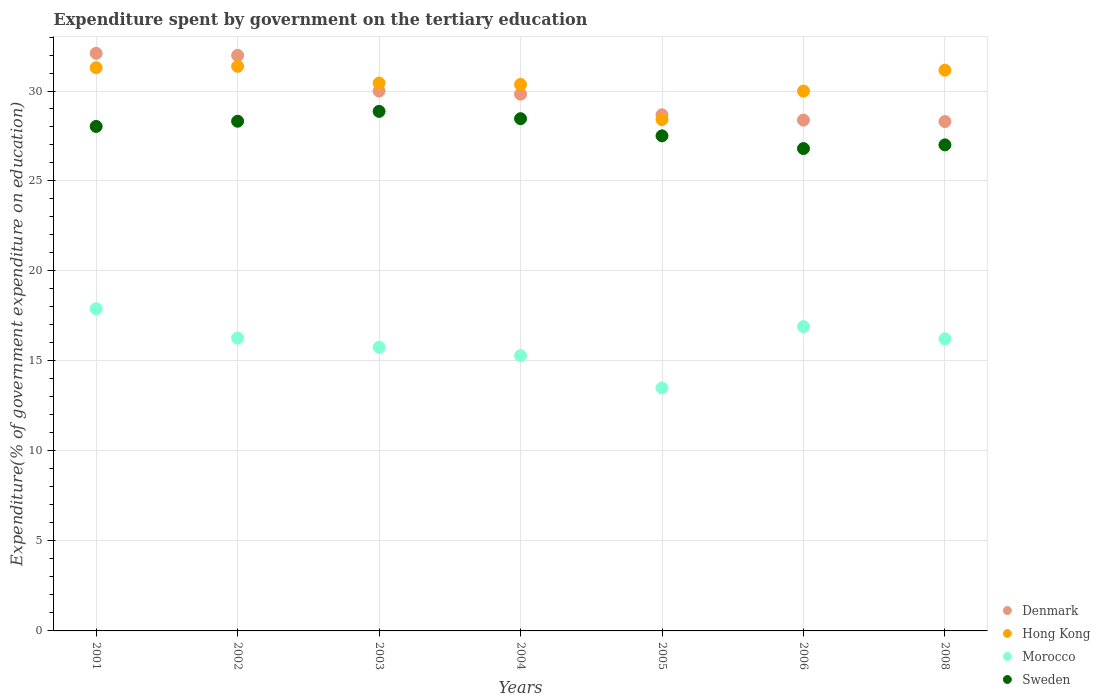How many different coloured dotlines are there?
Offer a terse response. 4. What is the expenditure spent by government on the tertiary education in Hong Kong in 2005?
Your answer should be very brief. 28.41. Across all years, what is the maximum expenditure spent by government on the tertiary education in Morocco?
Offer a terse response. 17.9. Across all years, what is the minimum expenditure spent by government on the tertiary education in Denmark?
Your answer should be very brief. 28.3. In which year was the expenditure spent by government on the tertiary education in Sweden maximum?
Offer a terse response. 2003. What is the total expenditure spent by government on the tertiary education in Hong Kong in the graph?
Provide a succinct answer. 213.04. What is the difference between the expenditure spent by government on the tertiary education in Hong Kong in 2001 and that in 2002?
Make the answer very short. -0.07. What is the difference between the expenditure spent by government on the tertiary education in Sweden in 2004 and the expenditure spent by government on the tertiary education in Denmark in 2005?
Make the answer very short. -0.22. What is the average expenditure spent by government on the tertiary education in Sweden per year?
Provide a succinct answer. 27.86. In the year 2005, what is the difference between the expenditure spent by government on the tertiary education in Denmark and expenditure spent by government on the tertiary education in Morocco?
Offer a terse response. 15.18. In how many years, is the expenditure spent by government on the tertiary education in Hong Kong greater than 29 %?
Ensure brevity in your answer.  6. What is the ratio of the expenditure spent by government on the tertiary education in Denmark in 2002 to that in 2006?
Offer a very short reply. 1.13. Is the expenditure spent by government on the tertiary education in Denmark in 2003 less than that in 2008?
Make the answer very short. No. What is the difference between the highest and the second highest expenditure spent by government on the tertiary education in Hong Kong?
Keep it short and to the point. 0.07. What is the difference between the highest and the lowest expenditure spent by government on the tertiary education in Sweden?
Your response must be concise. 2.07. In how many years, is the expenditure spent by government on the tertiary education in Denmark greater than the average expenditure spent by government on the tertiary education in Denmark taken over all years?
Provide a succinct answer. 3. Is the sum of the expenditure spent by government on the tertiary education in Hong Kong in 2003 and 2004 greater than the maximum expenditure spent by government on the tertiary education in Morocco across all years?
Provide a succinct answer. Yes. Is it the case that in every year, the sum of the expenditure spent by government on the tertiary education in Sweden and expenditure spent by government on the tertiary education in Denmark  is greater than the sum of expenditure spent by government on the tertiary education in Hong Kong and expenditure spent by government on the tertiary education in Morocco?
Make the answer very short. Yes. Does the expenditure spent by government on the tertiary education in Denmark monotonically increase over the years?
Keep it short and to the point. No. How many dotlines are there?
Your answer should be very brief. 4. How many years are there in the graph?
Ensure brevity in your answer.  7. Where does the legend appear in the graph?
Provide a succinct answer. Bottom right. What is the title of the graph?
Offer a terse response. Expenditure spent by government on the tertiary education. Does "Sweden" appear as one of the legend labels in the graph?
Provide a succinct answer. Yes. What is the label or title of the Y-axis?
Your response must be concise. Expenditure(% of government expenditure on education). What is the Expenditure(% of government expenditure on education) in Denmark in 2001?
Your answer should be compact. 32.09. What is the Expenditure(% of government expenditure on education) of Hong Kong in 2001?
Your response must be concise. 31.3. What is the Expenditure(% of government expenditure on education) of Morocco in 2001?
Keep it short and to the point. 17.9. What is the Expenditure(% of government expenditure on education) of Sweden in 2001?
Your answer should be compact. 28.03. What is the Expenditure(% of government expenditure on education) in Denmark in 2002?
Your response must be concise. 31.98. What is the Expenditure(% of government expenditure on education) of Hong Kong in 2002?
Provide a short and direct response. 31.37. What is the Expenditure(% of government expenditure on education) of Morocco in 2002?
Provide a short and direct response. 16.27. What is the Expenditure(% of government expenditure on education) in Sweden in 2002?
Give a very brief answer. 28.32. What is the Expenditure(% of government expenditure on education) of Denmark in 2003?
Provide a short and direct response. 30. What is the Expenditure(% of government expenditure on education) of Hong Kong in 2003?
Your response must be concise. 30.44. What is the Expenditure(% of government expenditure on education) of Morocco in 2003?
Give a very brief answer. 15.76. What is the Expenditure(% of government expenditure on education) of Sweden in 2003?
Ensure brevity in your answer.  28.87. What is the Expenditure(% of government expenditure on education) in Denmark in 2004?
Provide a short and direct response. 29.82. What is the Expenditure(% of government expenditure on education) in Hong Kong in 2004?
Provide a short and direct response. 30.36. What is the Expenditure(% of government expenditure on education) of Morocco in 2004?
Offer a terse response. 15.29. What is the Expenditure(% of government expenditure on education) of Sweden in 2004?
Ensure brevity in your answer.  28.46. What is the Expenditure(% of government expenditure on education) in Denmark in 2005?
Offer a terse response. 28.68. What is the Expenditure(% of government expenditure on education) of Hong Kong in 2005?
Your answer should be very brief. 28.41. What is the Expenditure(% of government expenditure on education) of Morocco in 2005?
Your answer should be very brief. 13.5. What is the Expenditure(% of government expenditure on education) of Sweden in 2005?
Give a very brief answer. 27.51. What is the Expenditure(% of government expenditure on education) in Denmark in 2006?
Ensure brevity in your answer.  28.38. What is the Expenditure(% of government expenditure on education) of Hong Kong in 2006?
Give a very brief answer. 30. What is the Expenditure(% of government expenditure on education) of Morocco in 2006?
Your response must be concise. 16.91. What is the Expenditure(% of government expenditure on education) in Sweden in 2006?
Your answer should be very brief. 26.8. What is the Expenditure(% of government expenditure on education) in Denmark in 2008?
Your answer should be very brief. 28.3. What is the Expenditure(% of government expenditure on education) of Hong Kong in 2008?
Provide a short and direct response. 31.16. What is the Expenditure(% of government expenditure on education) of Morocco in 2008?
Offer a very short reply. 16.23. What is the Expenditure(% of government expenditure on education) in Sweden in 2008?
Your response must be concise. 27.01. Across all years, what is the maximum Expenditure(% of government expenditure on education) in Denmark?
Provide a short and direct response. 32.09. Across all years, what is the maximum Expenditure(% of government expenditure on education) in Hong Kong?
Your answer should be very brief. 31.37. Across all years, what is the maximum Expenditure(% of government expenditure on education) in Morocco?
Offer a very short reply. 17.9. Across all years, what is the maximum Expenditure(% of government expenditure on education) in Sweden?
Offer a very short reply. 28.87. Across all years, what is the minimum Expenditure(% of government expenditure on education) in Denmark?
Ensure brevity in your answer.  28.3. Across all years, what is the minimum Expenditure(% of government expenditure on education) in Hong Kong?
Ensure brevity in your answer.  28.41. Across all years, what is the minimum Expenditure(% of government expenditure on education) in Morocco?
Give a very brief answer. 13.5. Across all years, what is the minimum Expenditure(% of government expenditure on education) in Sweden?
Offer a terse response. 26.8. What is the total Expenditure(% of government expenditure on education) in Denmark in the graph?
Give a very brief answer. 209.26. What is the total Expenditure(% of government expenditure on education) in Hong Kong in the graph?
Make the answer very short. 213.04. What is the total Expenditure(% of government expenditure on education) in Morocco in the graph?
Make the answer very short. 111.87. What is the total Expenditure(% of government expenditure on education) of Sweden in the graph?
Your answer should be very brief. 195. What is the difference between the Expenditure(% of government expenditure on education) of Denmark in 2001 and that in 2002?
Provide a succinct answer. 0.11. What is the difference between the Expenditure(% of government expenditure on education) of Hong Kong in 2001 and that in 2002?
Your answer should be compact. -0.07. What is the difference between the Expenditure(% of government expenditure on education) in Morocco in 2001 and that in 2002?
Your answer should be very brief. 1.63. What is the difference between the Expenditure(% of government expenditure on education) in Sweden in 2001 and that in 2002?
Offer a terse response. -0.29. What is the difference between the Expenditure(% of government expenditure on education) in Denmark in 2001 and that in 2003?
Your answer should be very brief. 2.1. What is the difference between the Expenditure(% of government expenditure on education) in Hong Kong in 2001 and that in 2003?
Your answer should be very brief. 0.85. What is the difference between the Expenditure(% of government expenditure on education) in Morocco in 2001 and that in 2003?
Your answer should be compact. 2.14. What is the difference between the Expenditure(% of government expenditure on education) in Sweden in 2001 and that in 2003?
Give a very brief answer. -0.84. What is the difference between the Expenditure(% of government expenditure on education) in Denmark in 2001 and that in 2004?
Make the answer very short. 2.27. What is the difference between the Expenditure(% of government expenditure on education) of Hong Kong in 2001 and that in 2004?
Your answer should be very brief. 0.93. What is the difference between the Expenditure(% of government expenditure on education) of Morocco in 2001 and that in 2004?
Provide a short and direct response. 2.61. What is the difference between the Expenditure(% of government expenditure on education) in Sweden in 2001 and that in 2004?
Make the answer very short. -0.43. What is the difference between the Expenditure(% of government expenditure on education) in Denmark in 2001 and that in 2005?
Make the answer very short. 3.42. What is the difference between the Expenditure(% of government expenditure on education) of Hong Kong in 2001 and that in 2005?
Provide a short and direct response. 2.88. What is the difference between the Expenditure(% of government expenditure on education) of Morocco in 2001 and that in 2005?
Make the answer very short. 4.4. What is the difference between the Expenditure(% of government expenditure on education) of Sweden in 2001 and that in 2005?
Your response must be concise. 0.52. What is the difference between the Expenditure(% of government expenditure on education) in Denmark in 2001 and that in 2006?
Provide a succinct answer. 3.71. What is the difference between the Expenditure(% of government expenditure on education) of Hong Kong in 2001 and that in 2006?
Your answer should be very brief. 1.3. What is the difference between the Expenditure(% of government expenditure on education) of Morocco in 2001 and that in 2006?
Provide a short and direct response. 0.99. What is the difference between the Expenditure(% of government expenditure on education) in Sweden in 2001 and that in 2006?
Your response must be concise. 1.23. What is the difference between the Expenditure(% of government expenditure on education) of Denmark in 2001 and that in 2008?
Offer a very short reply. 3.79. What is the difference between the Expenditure(% of government expenditure on education) in Hong Kong in 2001 and that in 2008?
Give a very brief answer. 0.14. What is the difference between the Expenditure(% of government expenditure on education) in Morocco in 2001 and that in 2008?
Your answer should be very brief. 1.67. What is the difference between the Expenditure(% of government expenditure on education) in Sweden in 2001 and that in 2008?
Keep it short and to the point. 1.02. What is the difference between the Expenditure(% of government expenditure on education) in Denmark in 2002 and that in 2003?
Offer a terse response. 1.98. What is the difference between the Expenditure(% of government expenditure on education) in Hong Kong in 2002 and that in 2003?
Keep it short and to the point. 0.93. What is the difference between the Expenditure(% of government expenditure on education) in Morocco in 2002 and that in 2003?
Provide a succinct answer. 0.51. What is the difference between the Expenditure(% of government expenditure on education) in Sweden in 2002 and that in 2003?
Your answer should be very brief. -0.55. What is the difference between the Expenditure(% of government expenditure on education) in Denmark in 2002 and that in 2004?
Provide a short and direct response. 2.16. What is the difference between the Expenditure(% of government expenditure on education) of Hong Kong in 2002 and that in 2004?
Your response must be concise. 1.01. What is the difference between the Expenditure(% of government expenditure on education) of Morocco in 2002 and that in 2004?
Ensure brevity in your answer.  0.98. What is the difference between the Expenditure(% of government expenditure on education) of Sweden in 2002 and that in 2004?
Make the answer very short. -0.14. What is the difference between the Expenditure(% of government expenditure on education) in Denmark in 2002 and that in 2005?
Ensure brevity in your answer.  3.3. What is the difference between the Expenditure(% of government expenditure on education) of Hong Kong in 2002 and that in 2005?
Provide a succinct answer. 2.96. What is the difference between the Expenditure(% of government expenditure on education) in Morocco in 2002 and that in 2005?
Offer a terse response. 2.77. What is the difference between the Expenditure(% of government expenditure on education) of Sweden in 2002 and that in 2005?
Keep it short and to the point. 0.81. What is the difference between the Expenditure(% of government expenditure on education) of Denmark in 2002 and that in 2006?
Your answer should be compact. 3.6. What is the difference between the Expenditure(% of government expenditure on education) of Hong Kong in 2002 and that in 2006?
Provide a short and direct response. 1.37. What is the difference between the Expenditure(% of government expenditure on education) in Morocco in 2002 and that in 2006?
Your answer should be compact. -0.64. What is the difference between the Expenditure(% of government expenditure on education) of Sweden in 2002 and that in 2006?
Your response must be concise. 1.52. What is the difference between the Expenditure(% of government expenditure on education) of Denmark in 2002 and that in 2008?
Make the answer very short. 3.68. What is the difference between the Expenditure(% of government expenditure on education) of Hong Kong in 2002 and that in 2008?
Your response must be concise. 0.21. What is the difference between the Expenditure(% of government expenditure on education) in Morocco in 2002 and that in 2008?
Keep it short and to the point. 0.04. What is the difference between the Expenditure(% of government expenditure on education) in Sweden in 2002 and that in 2008?
Your response must be concise. 1.31. What is the difference between the Expenditure(% of government expenditure on education) in Denmark in 2003 and that in 2004?
Provide a short and direct response. 0.17. What is the difference between the Expenditure(% of government expenditure on education) of Hong Kong in 2003 and that in 2004?
Your response must be concise. 0.08. What is the difference between the Expenditure(% of government expenditure on education) of Morocco in 2003 and that in 2004?
Your answer should be very brief. 0.47. What is the difference between the Expenditure(% of government expenditure on education) in Sweden in 2003 and that in 2004?
Ensure brevity in your answer.  0.41. What is the difference between the Expenditure(% of government expenditure on education) of Denmark in 2003 and that in 2005?
Your answer should be compact. 1.32. What is the difference between the Expenditure(% of government expenditure on education) in Hong Kong in 2003 and that in 2005?
Make the answer very short. 2.03. What is the difference between the Expenditure(% of government expenditure on education) in Morocco in 2003 and that in 2005?
Provide a short and direct response. 2.26. What is the difference between the Expenditure(% of government expenditure on education) of Sweden in 2003 and that in 2005?
Your response must be concise. 1.36. What is the difference between the Expenditure(% of government expenditure on education) in Denmark in 2003 and that in 2006?
Ensure brevity in your answer.  1.61. What is the difference between the Expenditure(% of government expenditure on education) in Hong Kong in 2003 and that in 2006?
Your response must be concise. 0.45. What is the difference between the Expenditure(% of government expenditure on education) of Morocco in 2003 and that in 2006?
Offer a terse response. -1.15. What is the difference between the Expenditure(% of government expenditure on education) in Sweden in 2003 and that in 2006?
Keep it short and to the point. 2.07. What is the difference between the Expenditure(% of government expenditure on education) in Denmark in 2003 and that in 2008?
Keep it short and to the point. 1.69. What is the difference between the Expenditure(% of government expenditure on education) in Hong Kong in 2003 and that in 2008?
Ensure brevity in your answer.  -0.71. What is the difference between the Expenditure(% of government expenditure on education) in Morocco in 2003 and that in 2008?
Ensure brevity in your answer.  -0.47. What is the difference between the Expenditure(% of government expenditure on education) of Sweden in 2003 and that in 2008?
Provide a short and direct response. 1.86. What is the difference between the Expenditure(% of government expenditure on education) in Denmark in 2004 and that in 2005?
Keep it short and to the point. 1.15. What is the difference between the Expenditure(% of government expenditure on education) in Hong Kong in 2004 and that in 2005?
Keep it short and to the point. 1.95. What is the difference between the Expenditure(% of government expenditure on education) in Morocco in 2004 and that in 2005?
Your answer should be compact. 1.79. What is the difference between the Expenditure(% of government expenditure on education) of Sweden in 2004 and that in 2005?
Your answer should be compact. 0.95. What is the difference between the Expenditure(% of government expenditure on education) in Denmark in 2004 and that in 2006?
Offer a terse response. 1.44. What is the difference between the Expenditure(% of government expenditure on education) of Hong Kong in 2004 and that in 2006?
Your response must be concise. 0.37. What is the difference between the Expenditure(% of government expenditure on education) in Morocco in 2004 and that in 2006?
Your response must be concise. -1.61. What is the difference between the Expenditure(% of government expenditure on education) in Sweden in 2004 and that in 2006?
Make the answer very short. 1.66. What is the difference between the Expenditure(% of government expenditure on education) of Denmark in 2004 and that in 2008?
Keep it short and to the point. 1.52. What is the difference between the Expenditure(% of government expenditure on education) in Hong Kong in 2004 and that in 2008?
Your response must be concise. -0.79. What is the difference between the Expenditure(% of government expenditure on education) of Morocco in 2004 and that in 2008?
Ensure brevity in your answer.  -0.94. What is the difference between the Expenditure(% of government expenditure on education) in Sweden in 2004 and that in 2008?
Offer a very short reply. 1.46. What is the difference between the Expenditure(% of government expenditure on education) in Denmark in 2005 and that in 2006?
Offer a very short reply. 0.3. What is the difference between the Expenditure(% of government expenditure on education) in Hong Kong in 2005 and that in 2006?
Ensure brevity in your answer.  -1.59. What is the difference between the Expenditure(% of government expenditure on education) in Morocco in 2005 and that in 2006?
Your answer should be very brief. -3.41. What is the difference between the Expenditure(% of government expenditure on education) in Sweden in 2005 and that in 2006?
Your answer should be very brief. 0.71. What is the difference between the Expenditure(% of government expenditure on education) in Denmark in 2005 and that in 2008?
Keep it short and to the point. 0.37. What is the difference between the Expenditure(% of government expenditure on education) in Hong Kong in 2005 and that in 2008?
Your response must be concise. -2.74. What is the difference between the Expenditure(% of government expenditure on education) of Morocco in 2005 and that in 2008?
Your answer should be very brief. -2.73. What is the difference between the Expenditure(% of government expenditure on education) in Sweden in 2005 and that in 2008?
Offer a very short reply. 0.5. What is the difference between the Expenditure(% of government expenditure on education) in Denmark in 2006 and that in 2008?
Ensure brevity in your answer.  0.08. What is the difference between the Expenditure(% of government expenditure on education) in Hong Kong in 2006 and that in 2008?
Offer a terse response. -1.16. What is the difference between the Expenditure(% of government expenditure on education) in Morocco in 2006 and that in 2008?
Provide a short and direct response. 0.68. What is the difference between the Expenditure(% of government expenditure on education) of Sweden in 2006 and that in 2008?
Make the answer very short. -0.2. What is the difference between the Expenditure(% of government expenditure on education) of Denmark in 2001 and the Expenditure(% of government expenditure on education) of Hong Kong in 2002?
Offer a very short reply. 0.72. What is the difference between the Expenditure(% of government expenditure on education) of Denmark in 2001 and the Expenditure(% of government expenditure on education) of Morocco in 2002?
Offer a very short reply. 15.82. What is the difference between the Expenditure(% of government expenditure on education) of Denmark in 2001 and the Expenditure(% of government expenditure on education) of Sweden in 2002?
Keep it short and to the point. 3.77. What is the difference between the Expenditure(% of government expenditure on education) in Hong Kong in 2001 and the Expenditure(% of government expenditure on education) in Morocco in 2002?
Keep it short and to the point. 15.02. What is the difference between the Expenditure(% of government expenditure on education) in Hong Kong in 2001 and the Expenditure(% of government expenditure on education) in Sweden in 2002?
Your response must be concise. 2.97. What is the difference between the Expenditure(% of government expenditure on education) of Morocco in 2001 and the Expenditure(% of government expenditure on education) of Sweden in 2002?
Provide a short and direct response. -10.42. What is the difference between the Expenditure(% of government expenditure on education) of Denmark in 2001 and the Expenditure(% of government expenditure on education) of Hong Kong in 2003?
Give a very brief answer. 1.65. What is the difference between the Expenditure(% of government expenditure on education) in Denmark in 2001 and the Expenditure(% of government expenditure on education) in Morocco in 2003?
Your answer should be compact. 16.33. What is the difference between the Expenditure(% of government expenditure on education) in Denmark in 2001 and the Expenditure(% of government expenditure on education) in Sweden in 2003?
Your response must be concise. 3.23. What is the difference between the Expenditure(% of government expenditure on education) in Hong Kong in 2001 and the Expenditure(% of government expenditure on education) in Morocco in 2003?
Make the answer very short. 15.53. What is the difference between the Expenditure(% of government expenditure on education) of Hong Kong in 2001 and the Expenditure(% of government expenditure on education) of Sweden in 2003?
Provide a short and direct response. 2.43. What is the difference between the Expenditure(% of government expenditure on education) of Morocco in 2001 and the Expenditure(% of government expenditure on education) of Sweden in 2003?
Offer a very short reply. -10.96. What is the difference between the Expenditure(% of government expenditure on education) in Denmark in 2001 and the Expenditure(% of government expenditure on education) in Hong Kong in 2004?
Ensure brevity in your answer.  1.73. What is the difference between the Expenditure(% of government expenditure on education) in Denmark in 2001 and the Expenditure(% of government expenditure on education) in Morocco in 2004?
Keep it short and to the point. 16.8. What is the difference between the Expenditure(% of government expenditure on education) of Denmark in 2001 and the Expenditure(% of government expenditure on education) of Sweden in 2004?
Your answer should be very brief. 3.63. What is the difference between the Expenditure(% of government expenditure on education) in Hong Kong in 2001 and the Expenditure(% of government expenditure on education) in Morocco in 2004?
Offer a very short reply. 16. What is the difference between the Expenditure(% of government expenditure on education) of Hong Kong in 2001 and the Expenditure(% of government expenditure on education) of Sweden in 2004?
Your response must be concise. 2.83. What is the difference between the Expenditure(% of government expenditure on education) in Morocco in 2001 and the Expenditure(% of government expenditure on education) in Sweden in 2004?
Your response must be concise. -10.56. What is the difference between the Expenditure(% of government expenditure on education) in Denmark in 2001 and the Expenditure(% of government expenditure on education) in Hong Kong in 2005?
Offer a terse response. 3.68. What is the difference between the Expenditure(% of government expenditure on education) in Denmark in 2001 and the Expenditure(% of government expenditure on education) in Morocco in 2005?
Offer a very short reply. 18.59. What is the difference between the Expenditure(% of government expenditure on education) in Denmark in 2001 and the Expenditure(% of government expenditure on education) in Sweden in 2005?
Your answer should be very brief. 4.59. What is the difference between the Expenditure(% of government expenditure on education) in Hong Kong in 2001 and the Expenditure(% of government expenditure on education) in Morocco in 2005?
Ensure brevity in your answer.  17.8. What is the difference between the Expenditure(% of government expenditure on education) in Hong Kong in 2001 and the Expenditure(% of government expenditure on education) in Sweden in 2005?
Keep it short and to the point. 3.79. What is the difference between the Expenditure(% of government expenditure on education) of Morocco in 2001 and the Expenditure(% of government expenditure on education) of Sweden in 2005?
Provide a succinct answer. -9.6. What is the difference between the Expenditure(% of government expenditure on education) in Denmark in 2001 and the Expenditure(% of government expenditure on education) in Hong Kong in 2006?
Your answer should be very brief. 2.1. What is the difference between the Expenditure(% of government expenditure on education) of Denmark in 2001 and the Expenditure(% of government expenditure on education) of Morocco in 2006?
Ensure brevity in your answer.  15.19. What is the difference between the Expenditure(% of government expenditure on education) of Denmark in 2001 and the Expenditure(% of government expenditure on education) of Sweden in 2006?
Provide a succinct answer. 5.29. What is the difference between the Expenditure(% of government expenditure on education) in Hong Kong in 2001 and the Expenditure(% of government expenditure on education) in Morocco in 2006?
Give a very brief answer. 14.39. What is the difference between the Expenditure(% of government expenditure on education) of Hong Kong in 2001 and the Expenditure(% of government expenditure on education) of Sweden in 2006?
Keep it short and to the point. 4.49. What is the difference between the Expenditure(% of government expenditure on education) of Morocco in 2001 and the Expenditure(% of government expenditure on education) of Sweden in 2006?
Offer a very short reply. -8.9. What is the difference between the Expenditure(% of government expenditure on education) of Denmark in 2001 and the Expenditure(% of government expenditure on education) of Hong Kong in 2008?
Give a very brief answer. 0.94. What is the difference between the Expenditure(% of government expenditure on education) of Denmark in 2001 and the Expenditure(% of government expenditure on education) of Morocco in 2008?
Ensure brevity in your answer.  15.86. What is the difference between the Expenditure(% of government expenditure on education) in Denmark in 2001 and the Expenditure(% of government expenditure on education) in Sweden in 2008?
Provide a short and direct response. 5.09. What is the difference between the Expenditure(% of government expenditure on education) in Hong Kong in 2001 and the Expenditure(% of government expenditure on education) in Morocco in 2008?
Your response must be concise. 15.07. What is the difference between the Expenditure(% of government expenditure on education) of Hong Kong in 2001 and the Expenditure(% of government expenditure on education) of Sweden in 2008?
Your answer should be compact. 4.29. What is the difference between the Expenditure(% of government expenditure on education) in Morocco in 2001 and the Expenditure(% of government expenditure on education) in Sweden in 2008?
Make the answer very short. -9.1. What is the difference between the Expenditure(% of government expenditure on education) in Denmark in 2002 and the Expenditure(% of government expenditure on education) in Hong Kong in 2003?
Your answer should be very brief. 1.54. What is the difference between the Expenditure(% of government expenditure on education) in Denmark in 2002 and the Expenditure(% of government expenditure on education) in Morocco in 2003?
Offer a terse response. 16.22. What is the difference between the Expenditure(% of government expenditure on education) in Denmark in 2002 and the Expenditure(% of government expenditure on education) in Sweden in 2003?
Your answer should be very brief. 3.11. What is the difference between the Expenditure(% of government expenditure on education) of Hong Kong in 2002 and the Expenditure(% of government expenditure on education) of Morocco in 2003?
Your answer should be compact. 15.61. What is the difference between the Expenditure(% of government expenditure on education) in Hong Kong in 2002 and the Expenditure(% of government expenditure on education) in Sweden in 2003?
Offer a very short reply. 2.5. What is the difference between the Expenditure(% of government expenditure on education) of Morocco in 2002 and the Expenditure(% of government expenditure on education) of Sweden in 2003?
Offer a terse response. -12.6. What is the difference between the Expenditure(% of government expenditure on education) of Denmark in 2002 and the Expenditure(% of government expenditure on education) of Hong Kong in 2004?
Give a very brief answer. 1.62. What is the difference between the Expenditure(% of government expenditure on education) of Denmark in 2002 and the Expenditure(% of government expenditure on education) of Morocco in 2004?
Ensure brevity in your answer.  16.69. What is the difference between the Expenditure(% of government expenditure on education) in Denmark in 2002 and the Expenditure(% of government expenditure on education) in Sweden in 2004?
Offer a very short reply. 3.52. What is the difference between the Expenditure(% of government expenditure on education) of Hong Kong in 2002 and the Expenditure(% of government expenditure on education) of Morocco in 2004?
Your answer should be compact. 16.08. What is the difference between the Expenditure(% of government expenditure on education) in Hong Kong in 2002 and the Expenditure(% of government expenditure on education) in Sweden in 2004?
Offer a terse response. 2.91. What is the difference between the Expenditure(% of government expenditure on education) in Morocco in 2002 and the Expenditure(% of government expenditure on education) in Sweden in 2004?
Make the answer very short. -12.19. What is the difference between the Expenditure(% of government expenditure on education) in Denmark in 2002 and the Expenditure(% of government expenditure on education) in Hong Kong in 2005?
Offer a terse response. 3.57. What is the difference between the Expenditure(% of government expenditure on education) in Denmark in 2002 and the Expenditure(% of government expenditure on education) in Morocco in 2005?
Your answer should be very brief. 18.48. What is the difference between the Expenditure(% of government expenditure on education) in Denmark in 2002 and the Expenditure(% of government expenditure on education) in Sweden in 2005?
Make the answer very short. 4.47. What is the difference between the Expenditure(% of government expenditure on education) in Hong Kong in 2002 and the Expenditure(% of government expenditure on education) in Morocco in 2005?
Offer a very short reply. 17.87. What is the difference between the Expenditure(% of government expenditure on education) of Hong Kong in 2002 and the Expenditure(% of government expenditure on education) of Sweden in 2005?
Make the answer very short. 3.86. What is the difference between the Expenditure(% of government expenditure on education) in Morocco in 2002 and the Expenditure(% of government expenditure on education) in Sweden in 2005?
Make the answer very short. -11.24. What is the difference between the Expenditure(% of government expenditure on education) in Denmark in 2002 and the Expenditure(% of government expenditure on education) in Hong Kong in 2006?
Your answer should be very brief. 1.98. What is the difference between the Expenditure(% of government expenditure on education) of Denmark in 2002 and the Expenditure(% of government expenditure on education) of Morocco in 2006?
Ensure brevity in your answer.  15.07. What is the difference between the Expenditure(% of government expenditure on education) in Denmark in 2002 and the Expenditure(% of government expenditure on education) in Sweden in 2006?
Give a very brief answer. 5.18. What is the difference between the Expenditure(% of government expenditure on education) of Hong Kong in 2002 and the Expenditure(% of government expenditure on education) of Morocco in 2006?
Provide a succinct answer. 14.46. What is the difference between the Expenditure(% of government expenditure on education) in Hong Kong in 2002 and the Expenditure(% of government expenditure on education) in Sweden in 2006?
Offer a terse response. 4.57. What is the difference between the Expenditure(% of government expenditure on education) in Morocco in 2002 and the Expenditure(% of government expenditure on education) in Sweden in 2006?
Provide a short and direct response. -10.53. What is the difference between the Expenditure(% of government expenditure on education) in Denmark in 2002 and the Expenditure(% of government expenditure on education) in Hong Kong in 2008?
Ensure brevity in your answer.  0.82. What is the difference between the Expenditure(% of government expenditure on education) of Denmark in 2002 and the Expenditure(% of government expenditure on education) of Morocco in 2008?
Provide a succinct answer. 15.75. What is the difference between the Expenditure(% of government expenditure on education) of Denmark in 2002 and the Expenditure(% of government expenditure on education) of Sweden in 2008?
Give a very brief answer. 4.97. What is the difference between the Expenditure(% of government expenditure on education) in Hong Kong in 2002 and the Expenditure(% of government expenditure on education) in Morocco in 2008?
Make the answer very short. 15.14. What is the difference between the Expenditure(% of government expenditure on education) of Hong Kong in 2002 and the Expenditure(% of government expenditure on education) of Sweden in 2008?
Provide a succinct answer. 4.36. What is the difference between the Expenditure(% of government expenditure on education) in Morocco in 2002 and the Expenditure(% of government expenditure on education) in Sweden in 2008?
Provide a succinct answer. -10.73. What is the difference between the Expenditure(% of government expenditure on education) in Denmark in 2003 and the Expenditure(% of government expenditure on education) in Hong Kong in 2004?
Your response must be concise. -0.37. What is the difference between the Expenditure(% of government expenditure on education) of Denmark in 2003 and the Expenditure(% of government expenditure on education) of Morocco in 2004?
Offer a terse response. 14.7. What is the difference between the Expenditure(% of government expenditure on education) of Denmark in 2003 and the Expenditure(% of government expenditure on education) of Sweden in 2004?
Offer a terse response. 1.53. What is the difference between the Expenditure(% of government expenditure on education) in Hong Kong in 2003 and the Expenditure(% of government expenditure on education) in Morocco in 2004?
Your answer should be very brief. 15.15. What is the difference between the Expenditure(% of government expenditure on education) in Hong Kong in 2003 and the Expenditure(% of government expenditure on education) in Sweden in 2004?
Offer a terse response. 1.98. What is the difference between the Expenditure(% of government expenditure on education) of Morocco in 2003 and the Expenditure(% of government expenditure on education) of Sweden in 2004?
Offer a very short reply. -12.7. What is the difference between the Expenditure(% of government expenditure on education) of Denmark in 2003 and the Expenditure(% of government expenditure on education) of Hong Kong in 2005?
Give a very brief answer. 1.58. What is the difference between the Expenditure(% of government expenditure on education) in Denmark in 2003 and the Expenditure(% of government expenditure on education) in Morocco in 2005?
Make the answer very short. 16.5. What is the difference between the Expenditure(% of government expenditure on education) of Denmark in 2003 and the Expenditure(% of government expenditure on education) of Sweden in 2005?
Your response must be concise. 2.49. What is the difference between the Expenditure(% of government expenditure on education) in Hong Kong in 2003 and the Expenditure(% of government expenditure on education) in Morocco in 2005?
Provide a succinct answer. 16.94. What is the difference between the Expenditure(% of government expenditure on education) of Hong Kong in 2003 and the Expenditure(% of government expenditure on education) of Sweden in 2005?
Your response must be concise. 2.94. What is the difference between the Expenditure(% of government expenditure on education) in Morocco in 2003 and the Expenditure(% of government expenditure on education) in Sweden in 2005?
Provide a succinct answer. -11.74. What is the difference between the Expenditure(% of government expenditure on education) of Denmark in 2003 and the Expenditure(% of government expenditure on education) of Hong Kong in 2006?
Provide a short and direct response. -0. What is the difference between the Expenditure(% of government expenditure on education) of Denmark in 2003 and the Expenditure(% of government expenditure on education) of Morocco in 2006?
Your answer should be compact. 13.09. What is the difference between the Expenditure(% of government expenditure on education) of Denmark in 2003 and the Expenditure(% of government expenditure on education) of Sweden in 2006?
Your response must be concise. 3.19. What is the difference between the Expenditure(% of government expenditure on education) in Hong Kong in 2003 and the Expenditure(% of government expenditure on education) in Morocco in 2006?
Keep it short and to the point. 13.54. What is the difference between the Expenditure(% of government expenditure on education) of Hong Kong in 2003 and the Expenditure(% of government expenditure on education) of Sweden in 2006?
Your response must be concise. 3.64. What is the difference between the Expenditure(% of government expenditure on education) in Morocco in 2003 and the Expenditure(% of government expenditure on education) in Sweden in 2006?
Offer a terse response. -11.04. What is the difference between the Expenditure(% of government expenditure on education) of Denmark in 2003 and the Expenditure(% of government expenditure on education) of Hong Kong in 2008?
Ensure brevity in your answer.  -1.16. What is the difference between the Expenditure(% of government expenditure on education) of Denmark in 2003 and the Expenditure(% of government expenditure on education) of Morocco in 2008?
Keep it short and to the point. 13.77. What is the difference between the Expenditure(% of government expenditure on education) of Denmark in 2003 and the Expenditure(% of government expenditure on education) of Sweden in 2008?
Make the answer very short. 2.99. What is the difference between the Expenditure(% of government expenditure on education) of Hong Kong in 2003 and the Expenditure(% of government expenditure on education) of Morocco in 2008?
Provide a succinct answer. 14.21. What is the difference between the Expenditure(% of government expenditure on education) of Hong Kong in 2003 and the Expenditure(% of government expenditure on education) of Sweden in 2008?
Your answer should be compact. 3.44. What is the difference between the Expenditure(% of government expenditure on education) of Morocco in 2003 and the Expenditure(% of government expenditure on education) of Sweden in 2008?
Your response must be concise. -11.24. What is the difference between the Expenditure(% of government expenditure on education) in Denmark in 2004 and the Expenditure(% of government expenditure on education) in Hong Kong in 2005?
Make the answer very short. 1.41. What is the difference between the Expenditure(% of government expenditure on education) of Denmark in 2004 and the Expenditure(% of government expenditure on education) of Morocco in 2005?
Give a very brief answer. 16.32. What is the difference between the Expenditure(% of government expenditure on education) in Denmark in 2004 and the Expenditure(% of government expenditure on education) in Sweden in 2005?
Your answer should be very brief. 2.32. What is the difference between the Expenditure(% of government expenditure on education) in Hong Kong in 2004 and the Expenditure(% of government expenditure on education) in Morocco in 2005?
Provide a succinct answer. 16.87. What is the difference between the Expenditure(% of government expenditure on education) of Hong Kong in 2004 and the Expenditure(% of government expenditure on education) of Sweden in 2005?
Provide a succinct answer. 2.86. What is the difference between the Expenditure(% of government expenditure on education) in Morocco in 2004 and the Expenditure(% of government expenditure on education) in Sweden in 2005?
Offer a very short reply. -12.21. What is the difference between the Expenditure(% of government expenditure on education) of Denmark in 2004 and the Expenditure(% of government expenditure on education) of Hong Kong in 2006?
Your answer should be compact. -0.17. What is the difference between the Expenditure(% of government expenditure on education) of Denmark in 2004 and the Expenditure(% of government expenditure on education) of Morocco in 2006?
Your answer should be very brief. 12.92. What is the difference between the Expenditure(% of government expenditure on education) of Denmark in 2004 and the Expenditure(% of government expenditure on education) of Sweden in 2006?
Keep it short and to the point. 3.02. What is the difference between the Expenditure(% of government expenditure on education) of Hong Kong in 2004 and the Expenditure(% of government expenditure on education) of Morocco in 2006?
Your answer should be very brief. 13.46. What is the difference between the Expenditure(% of government expenditure on education) in Hong Kong in 2004 and the Expenditure(% of government expenditure on education) in Sweden in 2006?
Your answer should be compact. 3.56. What is the difference between the Expenditure(% of government expenditure on education) of Morocco in 2004 and the Expenditure(% of government expenditure on education) of Sweden in 2006?
Ensure brevity in your answer.  -11.51. What is the difference between the Expenditure(% of government expenditure on education) in Denmark in 2004 and the Expenditure(% of government expenditure on education) in Hong Kong in 2008?
Offer a terse response. -1.33. What is the difference between the Expenditure(% of government expenditure on education) in Denmark in 2004 and the Expenditure(% of government expenditure on education) in Morocco in 2008?
Your answer should be compact. 13.59. What is the difference between the Expenditure(% of government expenditure on education) of Denmark in 2004 and the Expenditure(% of government expenditure on education) of Sweden in 2008?
Give a very brief answer. 2.82. What is the difference between the Expenditure(% of government expenditure on education) in Hong Kong in 2004 and the Expenditure(% of government expenditure on education) in Morocco in 2008?
Offer a very short reply. 14.14. What is the difference between the Expenditure(% of government expenditure on education) in Hong Kong in 2004 and the Expenditure(% of government expenditure on education) in Sweden in 2008?
Offer a very short reply. 3.36. What is the difference between the Expenditure(% of government expenditure on education) of Morocco in 2004 and the Expenditure(% of government expenditure on education) of Sweden in 2008?
Give a very brief answer. -11.71. What is the difference between the Expenditure(% of government expenditure on education) in Denmark in 2005 and the Expenditure(% of government expenditure on education) in Hong Kong in 2006?
Offer a very short reply. -1.32. What is the difference between the Expenditure(% of government expenditure on education) in Denmark in 2005 and the Expenditure(% of government expenditure on education) in Morocco in 2006?
Keep it short and to the point. 11.77. What is the difference between the Expenditure(% of government expenditure on education) of Denmark in 2005 and the Expenditure(% of government expenditure on education) of Sweden in 2006?
Give a very brief answer. 1.88. What is the difference between the Expenditure(% of government expenditure on education) of Hong Kong in 2005 and the Expenditure(% of government expenditure on education) of Morocco in 2006?
Offer a very short reply. 11.5. What is the difference between the Expenditure(% of government expenditure on education) in Hong Kong in 2005 and the Expenditure(% of government expenditure on education) in Sweden in 2006?
Offer a very short reply. 1.61. What is the difference between the Expenditure(% of government expenditure on education) in Morocco in 2005 and the Expenditure(% of government expenditure on education) in Sweden in 2006?
Ensure brevity in your answer.  -13.3. What is the difference between the Expenditure(% of government expenditure on education) of Denmark in 2005 and the Expenditure(% of government expenditure on education) of Hong Kong in 2008?
Offer a very short reply. -2.48. What is the difference between the Expenditure(% of government expenditure on education) of Denmark in 2005 and the Expenditure(% of government expenditure on education) of Morocco in 2008?
Your answer should be very brief. 12.45. What is the difference between the Expenditure(% of government expenditure on education) of Denmark in 2005 and the Expenditure(% of government expenditure on education) of Sweden in 2008?
Offer a very short reply. 1.67. What is the difference between the Expenditure(% of government expenditure on education) in Hong Kong in 2005 and the Expenditure(% of government expenditure on education) in Morocco in 2008?
Make the answer very short. 12.18. What is the difference between the Expenditure(% of government expenditure on education) in Hong Kong in 2005 and the Expenditure(% of government expenditure on education) in Sweden in 2008?
Provide a short and direct response. 1.4. What is the difference between the Expenditure(% of government expenditure on education) of Morocco in 2005 and the Expenditure(% of government expenditure on education) of Sweden in 2008?
Make the answer very short. -13.51. What is the difference between the Expenditure(% of government expenditure on education) in Denmark in 2006 and the Expenditure(% of government expenditure on education) in Hong Kong in 2008?
Provide a short and direct response. -2.77. What is the difference between the Expenditure(% of government expenditure on education) in Denmark in 2006 and the Expenditure(% of government expenditure on education) in Morocco in 2008?
Ensure brevity in your answer.  12.15. What is the difference between the Expenditure(% of government expenditure on education) in Denmark in 2006 and the Expenditure(% of government expenditure on education) in Sweden in 2008?
Keep it short and to the point. 1.38. What is the difference between the Expenditure(% of government expenditure on education) of Hong Kong in 2006 and the Expenditure(% of government expenditure on education) of Morocco in 2008?
Your answer should be compact. 13.77. What is the difference between the Expenditure(% of government expenditure on education) in Hong Kong in 2006 and the Expenditure(% of government expenditure on education) in Sweden in 2008?
Offer a terse response. 2.99. What is the difference between the Expenditure(% of government expenditure on education) in Morocco in 2006 and the Expenditure(% of government expenditure on education) in Sweden in 2008?
Your answer should be very brief. -10.1. What is the average Expenditure(% of government expenditure on education) of Denmark per year?
Your response must be concise. 29.89. What is the average Expenditure(% of government expenditure on education) in Hong Kong per year?
Give a very brief answer. 30.43. What is the average Expenditure(% of government expenditure on education) in Morocco per year?
Make the answer very short. 15.98. What is the average Expenditure(% of government expenditure on education) of Sweden per year?
Make the answer very short. 27.86. In the year 2001, what is the difference between the Expenditure(% of government expenditure on education) in Denmark and Expenditure(% of government expenditure on education) in Hong Kong?
Provide a succinct answer. 0.8. In the year 2001, what is the difference between the Expenditure(% of government expenditure on education) in Denmark and Expenditure(% of government expenditure on education) in Morocco?
Make the answer very short. 14.19. In the year 2001, what is the difference between the Expenditure(% of government expenditure on education) of Denmark and Expenditure(% of government expenditure on education) of Sweden?
Provide a short and direct response. 4.06. In the year 2001, what is the difference between the Expenditure(% of government expenditure on education) of Hong Kong and Expenditure(% of government expenditure on education) of Morocco?
Provide a short and direct response. 13.39. In the year 2001, what is the difference between the Expenditure(% of government expenditure on education) of Hong Kong and Expenditure(% of government expenditure on education) of Sweden?
Provide a succinct answer. 3.26. In the year 2001, what is the difference between the Expenditure(% of government expenditure on education) of Morocco and Expenditure(% of government expenditure on education) of Sweden?
Your response must be concise. -10.13. In the year 2002, what is the difference between the Expenditure(% of government expenditure on education) of Denmark and Expenditure(% of government expenditure on education) of Hong Kong?
Offer a terse response. 0.61. In the year 2002, what is the difference between the Expenditure(% of government expenditure on education) in Denmark and Expenditure(% of government expenditure on education) in Morocco?
Your answer should be compact. 15.71. In the year 2002, what is the difference between the Expenditure(% of government expenditure on education) in Denmark and Expenditure(% of government expenditure on education) in Sweden?
Ensure brevity in your answer.  3.66. In the year 2002, what is the difference between the Expenditure(% of government expenditure on education) in Hong Kong and Expenditure(% of government expenditure on education) in Morocco?
Give a very brief answer. 15.1. In the year 2002, what is the difference between the Expenditure(% of government expenditure on education) of Hong Kong and Expenditure(% of government expenditure on education) of Sweden?
Provide a short and direct response. 3.05. In the year 2002, what is the difference between the Expenditure(% of government expenditure on education) in Morocco and Expenditure(% of government expenditure on education) in Sweden?
Offer a terse response. -12.05. In the year 2003, what is the difference between the Expenditure(% of government expenditure on education) in Denmark and Expenditure(% of government expenditure on education) in Hong Kong?
Your answer should be very brief. -0.45. In the year 2003, what is the difference between the Expenditure(% of government expenditure on education) of Denmark and Expenditure(% of government expenditure on education) of Morocco?
Make the answer very short. 14.23. In the year 2003, what is the difference between the Expenditure(% of government expenditure on education) of Denmark and Expenditure(% of government expenditure on education) of Sweden?
Offer a very short reply. 1.13. In the year 2003, what is the difference between the Expenditure(% of government expenditure on education) of Hong Kong and Expenditure(% of government expenditure on education) of Morocco?
Your answer should be very brief. 14.68. In the year 2003, what is the difference between the Expenditure(% of government expenditure on education) in Hong Kong and Expenditure(% of government expenditure on education) in Sweden?
Provide a short and direct response. 1.58. In the year 2003, what is the difference between the Expenditure(% of government expenditure on education) of Morocco and Expenditure(% of government expenditure on education) of Sweden?
Ensure brevity in your answer.  -13.1. In the year 2004, what is the difference between the Expenditure(% of government expenditure on education) of Denmark and Expenditure(% of government expenditure on education) of Hong Kong?
Provide a short and direct response. -0.54. In the year 2004, what is the difference between the Expenditure(% of government expenditure on education) in Denmark and Expenditure(% of government expenditure on education) in Morocco?
Give a very brief answer. 14.53. In the year 2004, what is the difference between the Expenditure(% of government expenditure on education) in Denmark and Expenditure(% of government expenditure on education) in Sweden?
Provide a short and direct response. 1.36. In the year 2004, what is the difference between the Expenditure(% of government expenditure on education) of Hong Kong and Expenditure(% of government expenditure on education) of Morocco?
Offer a terse response. 15.07. In the year 2004, what is the difference between the Expenditure(% of government expenditure on education) of Hong Kong and Expenditure(% of government expenditure on education) of Sweden?
Keep it short and to the point. 1.9. In the year 2004, what is the difference between the Expenditure(% of government expenditure on education) of Morocco and Expenditure(% of government expenditure on education) of Sweden?
Your response must be concise. -13.17. In the year 2005, what is the difference between the Expenditure(% of government expenditure on education) in Denmark and Expenditure(% of government expenditure on education) in Hong Kong?
Your answer should be compact. 0.27. In the year 2005, what is the difference between the Expenditure(% of government expenditure on education) in Denmark and Expenditure(% of government expenditure on education) in Morocco?
Make the answer very short. 15.18. In the year 2005, what is the difference between the Expenditure(% of government expenditure on education) in Denmark and Expenditure(% of government expenditure on education) in Sweden?
Make the answer very short. 1.17. In the year 2005, what is the difference between the Expenditure(% of government expenditure on education) of Hong Kong and Expenditure(% of government expenditure on education) of Morocco?
Provide a short and direct response. 14.91. In the year 2005, what is the difference between the Expenditure(% of government expenditure on education) of Hong Kong and Expenditure(% of government expenditure on education) of Sweden?
Make the answer very short. 0.9. In the year 2005, what is the difference between the Expenditure(% of government expenditure on education) in Morocco and Expenditure(% of government expenditure on education) in Sweden?
Keep it short and to the point. -14.01. In the year 2006, what is the difference between the Expenditure(% of government expenditure on education) in Denmark and Expenditure(% of government expenditure on education) in Hong Kong?
Offer a very short reply. -1.61. In the year 2006, what is the difference between the Expenditure(% of government expenditure on education) in Denmark and Expenditure(% of government expenditure on education) in Morocco?
Make the answer very short. 11.47. In the year 2006, what is the difference between the Expenditure(% of government expenditure on education) in Denmark and Expenditure(% of government expenditure on education) in Sweden?
Keep it short and to the point. 1.58. In the year 2006, what is the difference between the Expenditure(% of government expenditure on education) of Hong Kong and Expenditure(% of government expenditure on education) of Morocco?
Ensure brevity in your answer.  13.09. In the year 2006, what is the difference between the Expenditure(% of government expenditure on education) of Hong Kong and Expenditure(% of government expenditure on education) of Sweden?
Make the answer very short. 3.19. In the year 2006, what is the difference between the Expenditure(% of government expenditure on education) in Morocco and Expenditure(% of government expenditure on education) in Sweden?
Offer a terse response. -9.89. In the year 2008, what is the difference between the Expenditure(% of government expenditure on education) in Denmark and Expenditure(% of government expenditure on education) in Hong Kong?
Offer a terse response. -2.85. In the year 2008, what is the difference between the Expenditure(% of government expenditure on education) of Denmark and Expenditure(% of government expenditure on education) of Morocco?
Offer a terse response. 12.07. In the year 2008, what is the difference between the Expenditure(% of government expenditure on education) of Denmark and Expenditure(% of government expenditure on education) of Sweden?
Provide a short and direct response. 1.3. In the year 2008, what is the difference between the Expenditure(% of government expenditure on education) of Hong Kong and Expenditure(% of government expenditure on education) of Morocco?
Provide a succinct answer. 14.93. In the year 2008, what is the difference between the Expenditure(% of government expenditure on education) of Hong Kong and Expenditure(% of government expenditure on education) of Sweden?
Provide a succinct answer. 4.15. In the year 2008, what is the difference between the Expenditure(% of government expenditure on education) of Morocco and Expenditure(% of government expenditure on education) of Sweden?
Ensure brevity in your answer.  -10.78. What is the ratio of the Expenditure(% of government expenditure on education) in Denmark in 2001 to that in 2002?
Give a very brief answer. 1. What is the ratio of the Expenditure(% of government expenditure on education) of Morocco in 2001 to that in 2002?
Your answer should be compact. 1.1. What is the ratio of the Expenditure(% of government expenditure on education) in Sweden in 2001 to that in 2002?
Your answer should be very brief. 0.99. What is the ratio of the Expenditure(% of government expenditure on education) of Denmark in 2001 to that in 2003?
Offer a very short reply. 1.07. What is the ratio of the Expenditure(% of government expenditure on education) in Hong Kong in 2001 to that in 2003?
Make the answer very short. 1.03. What is the ratio of the Expenditure(% of government expenditure on education) in Morocco in 2001 to that in 2003?
Ensure brevity in your answer.  1.14. What is the ratio of the Expenditure(% of government expenditure on education) in Sweden in 2001 to that in 2003?
Your answer should be compact. 0.97. What is the ratio of the Expenditure(% of government expenditure on education) of Denmark in 2001 to that in 2004?
Ensure brevity in your answer.  1.08. What is the ratio of the Expenditure(% of government expenditure on education) in Hong Kong in 2001 to that in 2004?
Give a very brief answer. 1.03. What is the ratio of the Expenditure(% of government expenditure on education) of Morocco in 2001 to that in 2004?
Keep it short and to the point. 1.17. What is the ratio of the Expenditure(% of government expenditure on education) in Sweden in 2001 to that in 2004?
Give a very brief answer. 0.98. What is the ratio of the Expenditure(% of government expenditure on education) in Denmark in 2001 to that in 2005?
Ensure brevity in your answer.  1.12. What is the ratio of the Expenditure(% of government expenditure on education) of Hong Kong in 2001 to that in 2005?
Keep it short and to the point. 1.1. What is the ratio of the Expenditure(% of government expenditure on education) of Morocco in 2001 to that in 2005?
Keep it short and to the point. 1.33. What is the ratio of the Expenditure(% of government expenditure on education) in Sweden in 2001 to that in 2005?
Provide a succinct answer. 1.02. What is the ratio of the Expenditure(% of government expenditure on education) of Denmark in 2001 to that in 2006?
Your answer should be very brief. 1.13. What is the ratio of the Expenditure(% of government expenditure on education) in Hong Kong in 2001 to that in 2006?
Keep it short and to the point. 1.04. What is the ratio of the Expenditure(% of government expenditure on education) of Morocco in 2001 to that in 2006?
Offer a very short reply. 1.06. What is the ratio of the Expenditure(% of government expenditure on education) in Sweden in 2001 to that in 2006?
Provide a short and direct response. 1.05. What is the ratio of the Expenditure(% of government expenditure on education) in Denmark in 2001 to that in 2008?
Your response must be concise. 1.13. What is the ratio of the Expenditure(% of government expenditure on education) of Morocco in 2001 to that in 2008?
Your response must be concise. 1.1. What is the ratio of the Expenditure(% of government expenditure on education) in Sweden in 2001 to that in 2008?
Provide a succinct answer. 1.04. What is the ratio of the Expenditure(% of government expenditure on education) in Denmark in 2002 to that in 2003?
Provide a succinct answer. 1.07. What is the ratio of the Expenditure(% of government expenditure on education) in Hong Kong in 2002 to that in 2003?
Your answer should be very brief. 1.03. What is the ratio of the Expenditure(% of government expenditure on education) in Morocco in 2002 to that in 2003?
Make the answer very short. 1.03. What is the ratio of the Expenditure(% of government expenditure on education) of Denmark in 2002 to that in 2004?
Offer a terse response. 1.07. What is the ratio of the Expenditure(% of government expenditure on education) of Hong Kong in 2002 to that in 2004?
Offer a terse response. 1.03. What is the ratio of the Expenditure(% of government expenditure on education) in Morocco in 2002 to that in 2004?
Your answer should be very brief. 1.06. What is the ratio of the Expenditure(% of government expenditure on education) of Denmark in 2002 to that in 2005?
Make the answer very short. 1.12. What is the ratio of the Expenditure(% of government expenditure on education) in Hong Kong in 2002 to that in 2005?
Give a very brief answer. 1.1. What is the ratio of the Expenditure(% of government expenditure on education) in Morocco in 2002 to that in 2005?
Provide a short and direct response. 1.21. What is the ratio of the Expenditure(% of government expenditure on education) in Sweden in 2002 to that in 2005?
Your answer should be compact. 1.03. What is the ratio of the Expenditure(% of government expenditure on education) of Denmark in 2002 to that in 2006?
Offer a very short reply. 1.13. What is the ratio of the Expenditure(% of government expenditure on education) of Hong Kong in 2002 to that in 2006?
Keep it short and to the point. 1.05. What is the ratio of the Expenditure(% of government expenditure on education) in Morocco in 2002 to that in 2006?
Provide a succinct answer. 0.96. What is the ratio of the Expenditure(% of government expenditure on education) of Sweden in 2002 to that in 2006?
Give a very brief answer. 1.06. What is the ratio of the Expenditure(% of government expenditure on education) in Denmark in 2002 to that in 2008?
Provide a short and direct response. 1.13. What is the ratio of the Expenditure(% of government expenditure on education) of Hong Kong in 2002 to that in 2008?
Your answer should be very brief. 1.01. What is the ratio of the Expenditure(% of government expenditure on education) of Morocco in 2002 to that in 2008?
Keep it short and to the point. 1. What is the ratio of the Expenditure(% of government expenditure on education) in Sweden in 2002 to that in 2008?
Provide a succinct answer. 1.05. What is the ratio of the Expenditure(% of government expenditure on education) of Denmark in 2003 to that in 2004?
Your response must be concise. 1.01. What is the ratio of the Expenditure(% of government expenditure on education) of Morocco in 2003 to that in 2004?
Ensure brevity in your answer.  1.03. What is the ratio of the Expenditure(% of government expenditure on education) of Sweden in 2003 to that in 2004?
Your response must be concise. 1.01. What is the ratio of the Expenditure(% of government expenditure on education) of Denmark in 2003 to that in 2005?
Your answer should be compact. 1.05. What is the ratio of the Expenditure(% of government expenditure on education) of Hong Kong in 2003 to that in 2005?
Your answer should be compact. 1.07. What is the ratio of the Expenditure(% of government expenditure on education) of Morocco in 2003 to that in 2005?
Your answer should be compact. 1.17. What is the ratio of the Expenditure(% of government expenditure on education) of Sweden in 2003 to that in 2005?
Provide a short and direct response. 1.05. What is the ratio of the Expenditure(% of government expenditure on education) in Denmark in 2003 to that in 2006?
Offer a very short reply. 1.06. What is the ratio of the Expenditure(% of government expenditure on education) of Hong Kong in 2003 to that in 2006?
Offer a very short reply. 1.01. What is the ratio of the Expenditure(% of government expenditure on education) of Morocco in 2003 to that in 2006?
Provide a succinct answer. 0.93. What is the ratio of the Expenditure(% of government expenditure on education) in Sweden in 2003 to that in 2006?
Provide a succinct answer. 1.08. What is the ratio of the Expenditure(% of government expenditure on education) of Denmark in 2003 to that in 2008?
Provide a short and direct response. 1.06. What is the ratio of the Expenditure(% of government expenditure on education) in Hong Kong in 2003 to that in 2008?
Your answer should be very brief. 0.98. What is the ratio of the Expenditure(% of government expenditure on education) of Morocco in 2003 to that in 2008?
Provide a short and direct response. 0.97. What is the ratio of the Expenditure(% of government expenditure on education) of Sweden in 2003 to that in 2008?
Your answer should be compact. 1.07. What is the ratio of the Expenditure(% of government expenditure on education) in Denmark in 2004 to that in 2005?
Provide a short and direct response. 1.04. What is the ratio of the Expenditure(% of government expenditure on education) in Hong Kong in 2004 to that in 2005?
Keep it short and to the point. 1.07. What is the ratio of the Expenditure(% of government expenditure on education) in Morocco in 2004 to that in 2005?
Ensure brevity in your answer.  1.13. What is the ratio of the Expenditure(% of government expenditure on education) in Sweden in 2004 to that in 2005?
Ensure brevity in your answer.  1.03. What is the ratio of the Expenditure(% of government expenditure on education) of Denmark in 2004 to that in 2006?
Keep it short and to the point. 1.05. What is the ratio of the Expenditure(% of government expenditure on education) of Hong Kong in 2004 to that in 2006?
Your answer should be compact. 1.01. What is the ratio of the Expenditure(% of government expenditure on education) of Morocco in 2004 to that in 2006?
Provide a short and direct response. 0.9. What is the ratio of the Expenditure(% of government expenditure on education) in Sweden in 2004 to that in 2006?
Your answer should be compact. 1.06. What is the ratio of the Expenditure(% of government expenditure on education) in Denmark in 2004 to that in 2008?
Provide a short and direct response. 1.05. What is the ratio of the Expenditure(% of government expenditure on education) of Hong Kong in 2004 to that in 2008?
Give a very brief answer. 0.97. What is the ratio of the Expenditure(% of government expenditure on education) of Morocco in 2004 to that in 2008?
Provide a short and direct response. 0.94. What is the ratio of the Expenditure(% of government expenditure on education) in Sweden in 2004 to that in 2008?
Your answer should be compact. 1.05. What is the ratio of the Expenditure(% of government expenditure on education) of Denmark in 2005 to that in 2006?
Your response must be concise. 1.01. What is the ratio of the Expenditure(% of government expenditure on education) of Hong Kong in 2005 to that in 2006?
Offer a terse response. 0.95. What is the ratio of the Expenditure(% of government expenditure on education) of Morocco in 2005 to that in 2006?
Your answer should be compact. 0.8. What is the ratio of the Expenditure(% of government expenditure on education) of Sweden in 2005 to that in 2006?
Your response must be concise. 1.03. What is the ratio of the Expenditure(% of government expenditure on education) of Denmark in 2005 to that in 2008?
Provide a short and direct response. 1.01. What is the ratio of the Expenditure(% of government expenditure on education) of Hong Kong in 2005 to that in 2008?
Your response must be concise. 0.91. What is the ratio of the Expenditure(% of government expenditure on education) of Morocco in 2005 to that in 2008?
Your answer should be very brief. 0.83. What is the ratio of the Expenditure(% of government expenditure on education) of Sweden in 2005 to that in 2008?
Provide a succinct answer. 1.02. What is the ratio of the Expenditure(% of government expenditure on education) in Hong Kong in 2006 to that in 2008?
Provide a succinct answer. 0.96. What is the ratio of the Expenditure(% of government expenditure on education) in Morocco in 2006 to that in 2008?
Provide a short and direct response. 1.04. What is the difference between the highest and the second highest Expenditure(% of government expenditure on education) of Denmark?
Your answer should be very brief. 0.11. What is the difference between the highest and the second highest Expenditure(% of government expenditure on education) of Hong Kong?
Provide a short and direct response. 0.07. What is the difference between the highest and the second highest Expenditure(% of government expenditure on education) in Morocco?
Ensure brevity in your answer.  0.99. What is the difference between the highest and the second highest Expenditure(% of government expenditure on education) in Sweden?
Provide a succinct answer. 0.41. What is the difference between the highest and the lowest Expenditure(% of government expenditure on education) in Denmark?
Your answer should be compact. 3.79. What is the difference between the highest and the lowest Expenditure(% of government expenditure on education) in Hong Kong?
Your answer should be compact. 2.96. What is the difference between the highest and the lowest Expenditure(% of government expenditure on education) in Morocco?
Your answer should be compact. 4.4. What is the difference between the highest and the lowest Expenditure(% of government expenditure on education) in Sweden?
Make the answer very short. 2.07. 